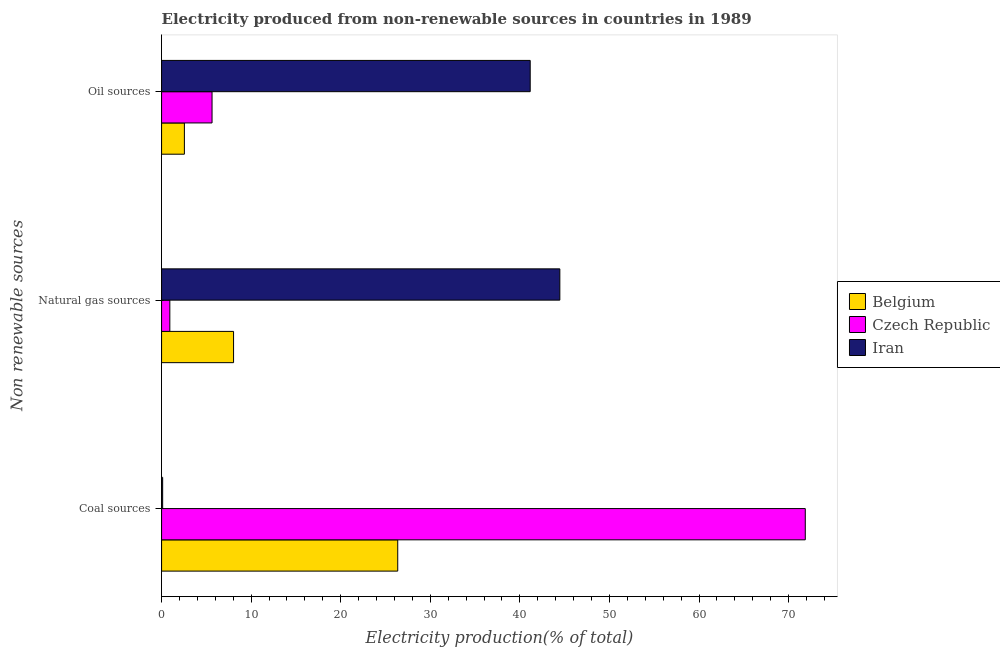Are the number of bars on each tick of the Y-axis equal?
Provide a succinct answer. Yes. How many bars are there on the 3rd tick from the top?
Provide a succinct answer. 3. How many bars are there on the 2nd tick from the bottom?
Provide a short and direct response. 3. What is the label of the 1st group of bars from the top?
Provide a succinct answer. Oil sources. What is the percentage of electricity produced by natural gas in Iran?
Ensure brevity in your answer.  44.46. Across all countries, what is the maximum percentage of electricity produced by natural gas?
Provide a short and direct response. 44.46. Across all countries, what is the minimum percentage of electricity produced by natural gas?
Offer a terse response. 0.92. In which country was the percentage of electricity produced by coal maximum?
Your response must be concise. Czech Republic. In which country was the percentage of electricity produced by coal minimum?
Provide a succinct answer. Iran. What is the total percentage of electricity produced by natural gas in the graph?
Your answer should be compact. 53.42. What is the difference between the percentage of electricity produced by oil sources in Belgium and that in Iran?
Offer a terse response. -38.6. What is the difference between the percentage of electricity produced by coal in Belgium and the percentage of electricity produced by oil sources in Iran?
Provide a succinct answer. -14.79. What is the average percentage of electricity produced by oil sources per country?
Offer a very short reply. 16.44. What is the difference between the percentage of electricity produced by coal and percentage of electricity produced by natural gas in Czech Republic?
Offer a very short reply. 70.93. In how many countries, is the percentage of electricity produced by oil sources greater than 48 %?
Offer a very short reply. 0. What is the ratio of the percentage of electricity produced by oil sources in Belgium to that in Iran?
Provide a succinct answer. 0.06. What is the difference between the highest and the second highest percentage of electricity produced by coal?
Your answer should be very brief. 45.49. What is the difference between the highest and the lowest percentage of electricity produced by coal?
Make the answer very short. 71.73. Is the sum of the percentage of electricity produced by natural gas in Czech Republic and Belgium greater than the maximum percentage of electricity produced by coal across all countries?
Make the answer very short. No. What does the 1st bar from the top in Coal sources represents?
Your answer should be compact. Iran. What does the 2nd bar from the bottom in Coal sources represents?
Provide a short and direct response. Czech Republic. Are all the bars in the graph horizontal?
Give a very brief answer. Yes. How many countries are there in the graph?
Your response must be concise. 3. How many legend labels are there?
Make the answer very short. 3. How are the legend labels stacked?
Keep it short and to the point. Vertical. What is the title of the graph?
Give a very brief answer. Electricity produced from non-renewable sources in countries in 1989. What is the label or title of the Y-axis?
Keep it short and to the point. Non renewable sources. What is the Electricity production(% of total) of Belgium in Coal sources?
Provide a short and direct response. 26.36. What is the Electricity production(% of total) in Czech Republic in Coal sources?
Offer a very short reply. 71.86. What is the Electricity production(% of total) in Iran in Coal sources?
Provide a short and direct response. 0.12. What is the Electricity production(% of total) in Belgium in Natural gas sources?
Provide a succinct answer. 8.04. What is the Electricity production(% of total) in Czech Republic in Natural gas sources?
Your response must be concise. 0.92. What is the Electricity production(% of total) of Iran in Natural gas sources?
Offer a terse response. 44.46. What is the Electricity production(% of total) in Belgium in Oil sources?
Ensure brevity in your answer.  2.55. What is the Electricity production(% of total) in Czech Republic in Oil sources?
Your answer should be compact. 5.63. What is the Electricity production(% of total) in Iran in Oil sources?
Offer a terse response. 41.15. Across all Non renewable sources, what is the maximum Electricity production(% of total) in Belgium?
Keep it short and to the point. 26.36. Across all Non renewable sources, what is the maximum Electricity production(% of total) of Czech Republic?
Your answer should be very brief. 71.86. Across all Non renewable sources, what is the maximum Electricity production(% of total) of Iran?
Keep it short and to the point. 44.46. Across all Non renewable sources, what is the minimum Electricity production(% of total) in Belgium?
Provide a succinct answer. 2.55. Across all Non renewable sources, what is the minimum Electricity production(% of total) in Czech Republic?
Provide a short and direct response. 0.92. Across all Non renewable sources, what is the minimum Electricity production(% of total) in Iran?
Your answer should be compact. 0.12. What is the total Electricity production(% of total) in Belgium in the graph?
Your answer should be compact. 36.94. What is the total Electricity production(% of total) in Czech Republic in the graph?
Ensure brevity in your answer.  78.41. What is the total Electricity production(% of total) of Iran in the graph?
Provide a succinct answer. 85.73. What is the difference between the Electricity production(% of total) in Belgium in Coal sources and that in Natural gas sources?
Provide a succinct answer. 18.33. What is the difference between the Electricity production(% of total) of Czech Republic in Coal sources and that in Natural gas sources?
Your answer should be compact. 70.93. What is the difference between the Electricity production(% of total) of Iran in Coal sources and that in Natural gas sources?
Your answer should be compact. -44.34. What is the difference between the Electricity production(% of total) in Belgium in Coal sources and that in Oil sources?
Offer a very short reply. 23.82. What is the difference between the Electricity production(% of total) of Czech Republic in Coal sources and that in Oil sources?
Make the answer very short. 66.22. What is the difference between the Electricity production(% of total) in Iran in Coal sources and that in Oil sources?
Ensure brevity in your answer.  -41.03. What is the difference between the Electricity production(% of total) in Belgium in Natural gas sources and that in Oil sources?
Your answer should be very brief. 5.49. What is the difference between the Electricity production(% of total) in Czech Republic in Natural gas sources and that in Oil sources?
Offer a terse response. -4.71. What is the difference between the Electricity production(% of total) of Iran in Natural gas sources and that in Oil sources?
Offer a terse response. 3.31. What is the difference between the Electricity production(% of total) in Belgium in Coal sources and the Electricity production(% of total) in Czech Republic in Natural gas sources?
Your answer should be very brief. 25.44. What is the difference between the Electricity production(% of total) of Belgium in Coal sources and the Electricity production(% of total) of Iran in Natural gas sources?
Provide a short and direct response. -18.1. What is the difference between the Electricity production(% of total) in Czech Republic in Coal sources and the Electricity production(% of total) in Iran in Natural gas sources?
Your answer should be very brief. 27.4. What is the difference between the Electricity production(% of total) of Belgium in Coal sources and the Electricity production(% of total) of Czech Republic in Oil sources?
Provide a short and direct response. 20.73. What is the difference between the Electricity production(% of total) in Belgium in Coal sources and the Electricity production(% of total) in Iran in Oil sources?
Your answer should be compact. -14.79. What is the difference between the Electricity production(% of total) of Czech Republic in Coal sources and the Electricity production(% of total) of Iran in Oil sources?
Provide a short and direct response. 30.71. What is the difference between the Electricity production(% of total) in Belgium in Natural gas sources and the Electricity production(% of total) in Czech Republic in Oil sources?
Your answer should be very brief. 2.4. What is the difference between the Electricity production(% of total) in Belgium in Natural gas sources and the Electricity production(% of total) in Iran in Oil sources?
Provide a succinct answer. -33.11. What is the difference between the Electricity production(% of total) in Czech Republic in Natural gas sources and the Electricity production(% of total) in Iran in Oil sources?
Provide a short and direct response. -40.23. What is the average Electricity production(% of total) in Belgium per Non renewable sources?
Your answer should be compact. 12.31. What is the average Electricity production(% of total) of Czech Republic per Non renewable sources?
Your response must be concise. 26.14. What is the average Electricity production(% of total) in Iran per Non renewable sources?
Offer a terse response. 28.58. What is the difference between the Electricity production(% of total) in Belgium and Electricity production(% of total) in Czech Republic in Coal sources?
Provide a succinct answer. -45.49. What is the difference between the Electricity production(% of total) in Belgium and Electricity production(% of total) in Iran in Coal sources?
Provide a succinct answer. 26.24. What is the difference between the Electricity production(% of total) in Czech Republic and Electricity production(% of total) in Iran in Coal sources?
Keep it short and to the point. 71.73. What is the difference between the Electricity production(% of total) of Belgium and Electricity production(% of total) of Czech Republic in Natural gas sources?
Your response must be concise. 7.11. What is the difference between the Electricity production(% of total) in Belgium and Electricity production(% of total) in Iran in Natural gas sources?
Provide a short and direct response. -36.42. What is the difference between the Electricity production(% of total) in Czech Republic and Electricity production(% of total) in Iran in Natural gas sources?
Provide a short and direct response. -43.54. What is the difference between the Electricity production(% of total) in Belgium and Electricity production(% of total) in Czech Republic in Oil sources?
Your answer should be compact. -3.09. What is the difference between the Electricity production(% of total) in Belgium and Electricity production(% of total) in Iran in Oil sources?
Make the answer very short. -38.6. What is the difference between the Electricity production(% of total) of Czech Republic and Electricity production(% of total) of Iran in Oil sources?
Make the answer very short. -35.52. What is the ratio of the Electricity production(% of total) in Belgium in Coal sources to that in Natural gas sources?
Your response must be concise. 3.28. What is the ratio of the Electricity production(% of total) of Czech Republic in Coal sources to that in Natural gas sources?
Your answer should be very brief. 78. What is the ratio of the Electricity production(% of total) in Iran in Coal sources to that in Natural gas sources?
Give a very brief answer. 0. What is the ratio of the Electricity production(% of total) in Belgium in Coal sources to that in Oil sources?
Make the answer very short. 10.35. What is the ratio of the Electricity production(% of total) in Czech Republic in Coal sources to that in Oil sources?
Your answer should be very brief. 12.75. What is the ratio of the Electricity production(% of total) of Iran in Coal sources to that in Oil sources?
Offer a terse response. 0. What is the ratio of the Electricity production(% of total) of Belgium in Natural gas sources to that in Oil sources?
Offer a very short reply. 3.16. What is the ratio of the Electricity production(% of total) in Czech Republic in Natural gas sources to that in Oil sources?
Make the answer very short. 0.16. What is the ratio of the Electricity production(% of total) in Iran in Natural gas sources to that in Oil sources?
Offer a very short reply. 1.08. What is the difference between the highest and the second highest Electricity production(% of total) in Belgium?
Your answer should be very brief. 18.33. What is the difference between the highest and the second highest Electricity production(% of total) in Czech Republic?
Offer a very short reply. 66.22. What is the difference between the highest and the second highest Electricity production(% of total) in Iran?
Provide a short and direct response. 3.31. What is the difference between the highest and the lowest Electricity production(% of total) of Belgium?
Your answer should be compact. 23.82. What is the difference between the highest and the lowest Electricity production(% of total) in Czech Republic?
Provide a succinct answer. 70.93. What is the difference between the highest and the lowest Electricity production(% of total) in Iran?
Give a very brief answer. 44.34. 